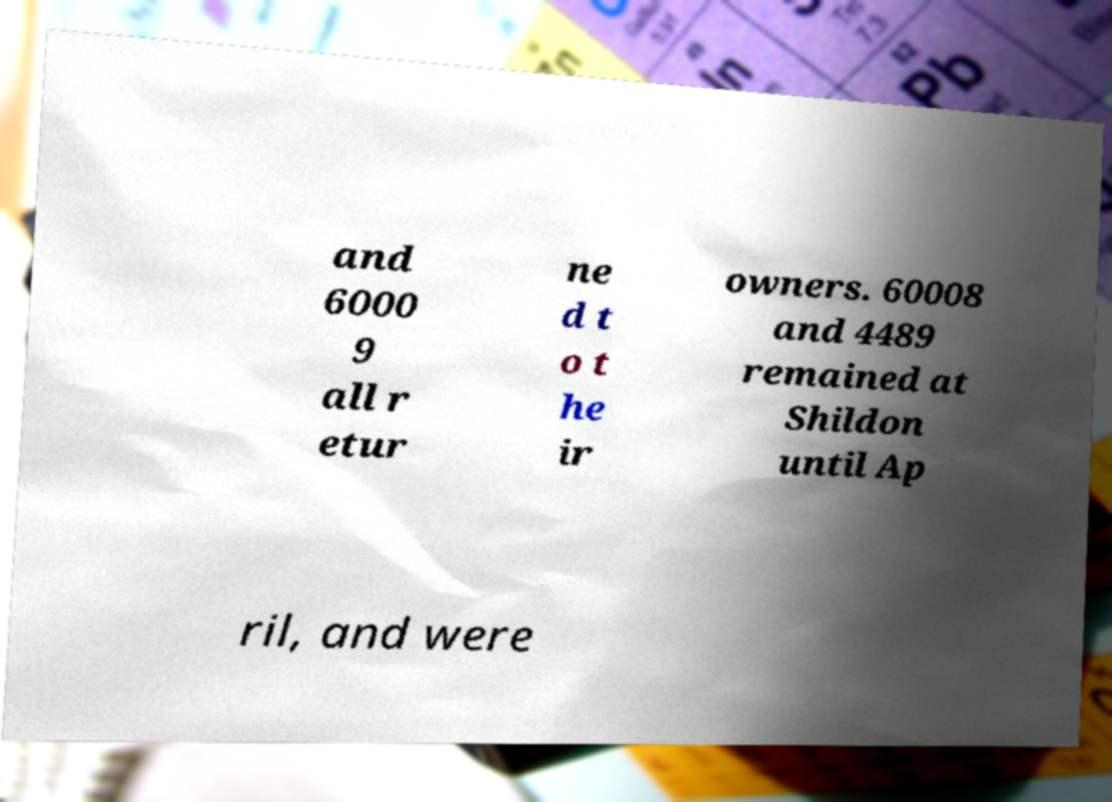Please identify and transcribe the text found in this image. and 6000 9 all r etur ne d t o t he ir owners. 60008 and 4489 remained at Shildon until Ap ril, and were 